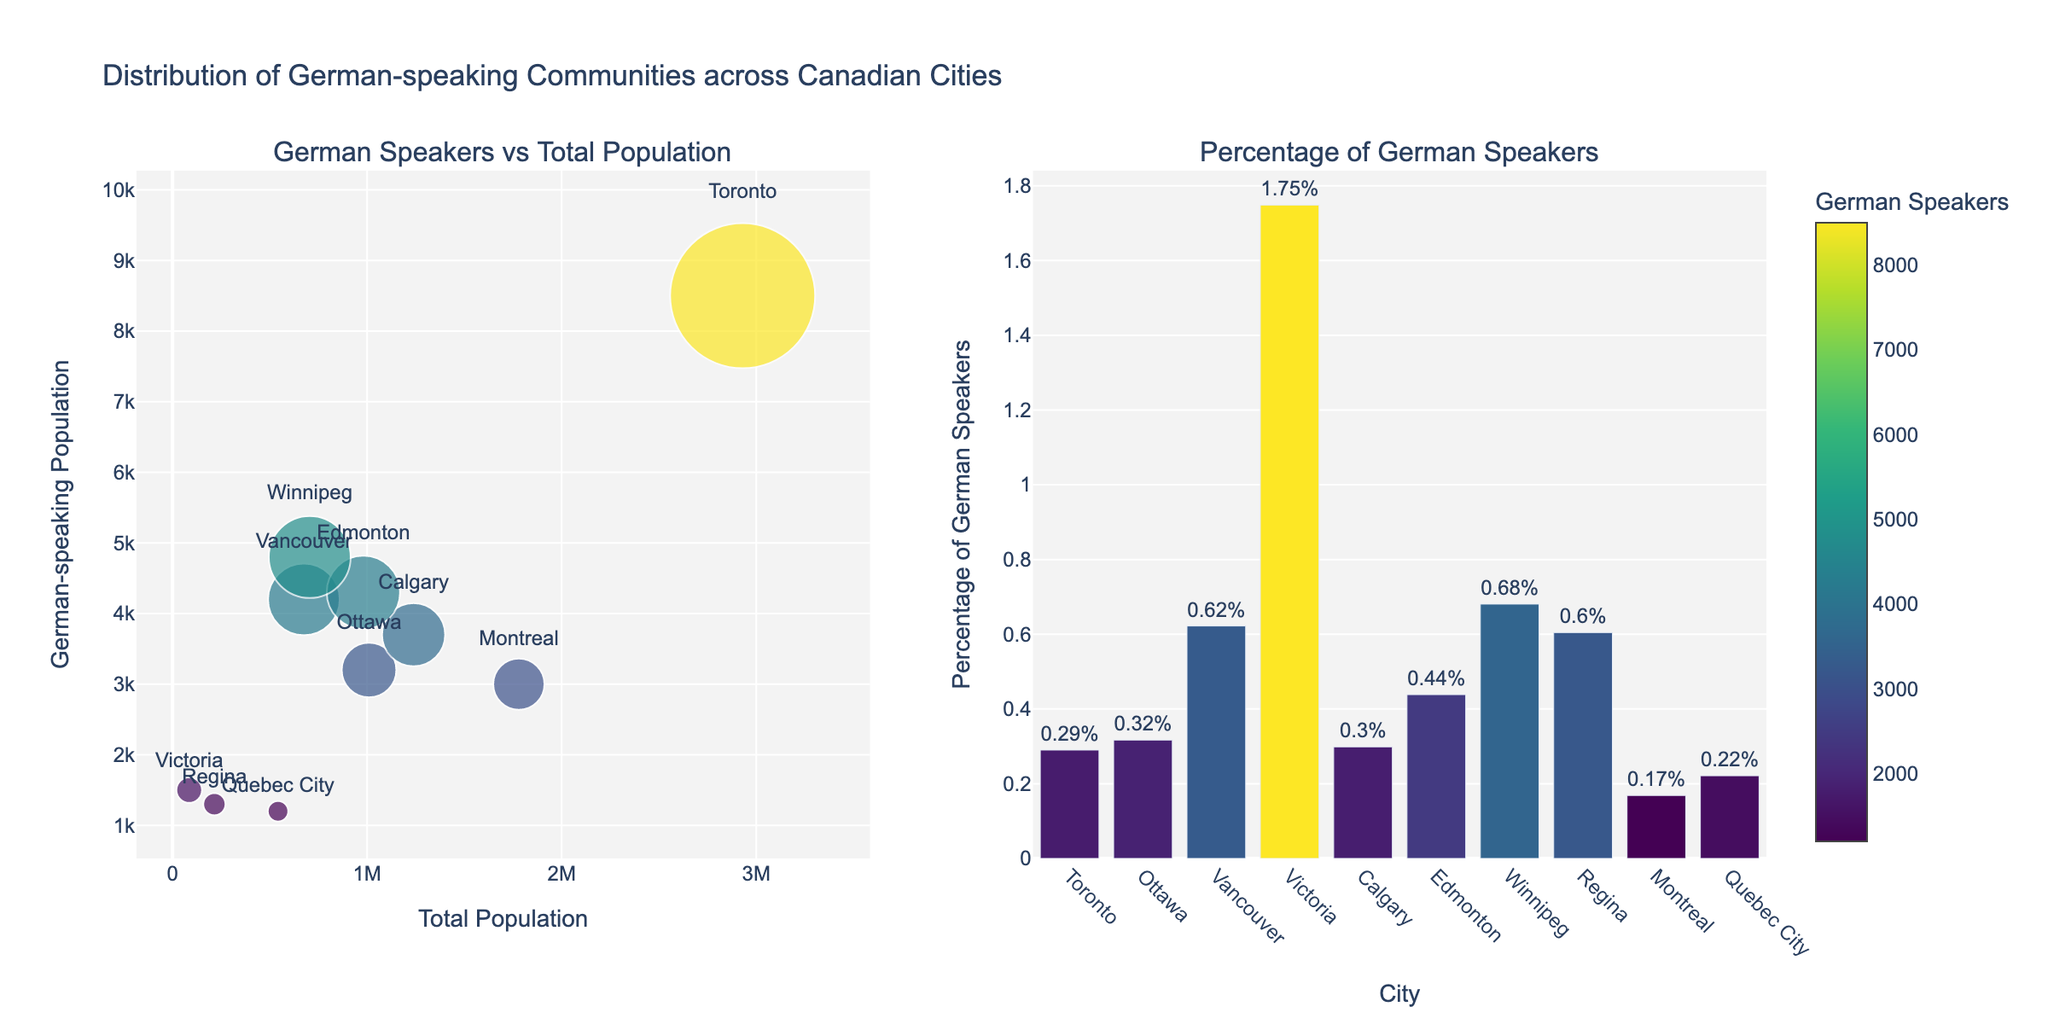What is the title of the figure? The title of a figure is usually prominently displayed at the top. It provides an overview of the topic or data presented in the figure.
Answer: Distribution of German-speaking Communities across Canadian Cities What are the axes labels in the scatter plot? Axes labels in a plot are typically located along the sides of the axes and describe the data presented in that dimension. In this scatter plot, the x-axis label is "Total Population", and the y-axis label is "German-speaking Population".
Answer: x-axis: Total Population, y-axis: German-speaking Population Which city has the largest number of German speakers? From the scatter plot, by examining the y-axis values, we can identify which city has the highest 'Population_Speaking_German'. The city associated with the highest point on the y-axis is Winnipeg.
Answer: Winnipeg Which city has the smallest percentage of German speakers? In the bar chart subplot, by looking at the bars representing the percentages of German speakers, we can determine that Quebec City has the smallest percentage.
Answer: Quebec City How does the population of German speakers in Toronto compare to that in Ottawa? In the scatter plot, compare the y-axis values (Population_Speaking_German) for Toronto and Ottawa. Toronto has 8500 German speakers, whereas Ottawa has 3200. Compare these values directly.
Answer: Toronto has more What is the percentage of German speakers in Vancouver? Check the height of the bar corresponding to Vancouver in the bar chart subplot. The text label on the bar gives the exact percentage. Vancouver's bar shows a percentage of approximately 0.62%.
Answer: 0.62% Which city has the highest percentage of German speakers relative to its total population? Examine the bar chart to see which city has the tallest bar representing the highest percentage of German speakers. Winnipeg has the tallest bar, indicating it has the highest percentage.
Answer: Winnipeg What is the total population of Calgary? In the scatter plot, locate the data point for Calgary and read the x-axis value corresponding to it. The x-axis shows the 'Total Population'. Calgary's total population is approximately 1239000.
Answer: 1239000 What is the combined population of German speakers in Toronto and Vancouver? From the scatter plot, get the values for 'Population_Speaking_German' for both Toronto (8500) and Vancouver (4200) and sum them up: 8500 + 4200 = 12700.
Answer: 12700 How does the German-speaking population in Edmonton compare to that in Calgary? Look at the y-axis values for both Edmonton (4300) and Calgary (3700) in the scatter plot. Edmonton's German-speaking population is higher than Calgary's.
Answer: Edmonton has more 